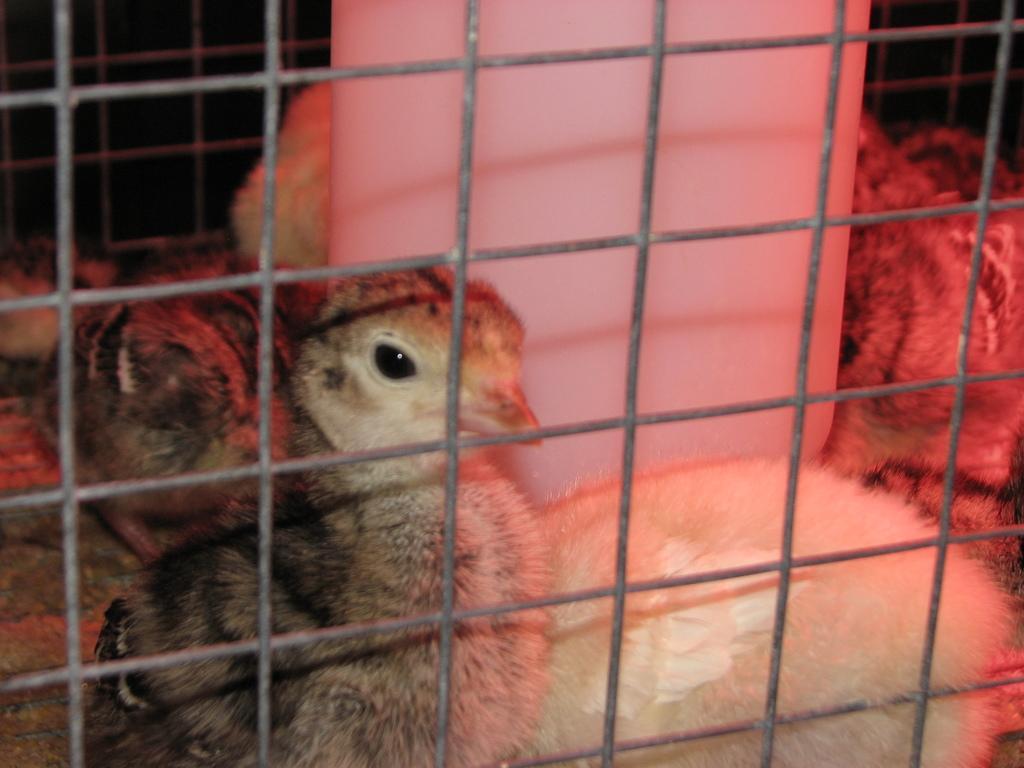In one or two sentences, can you explain what this image depicts? In this image I can see the metal cage and in the cage I can see few birds which are brown, black and cream in color and the white colored object in the cage. I can see the black colored background. 